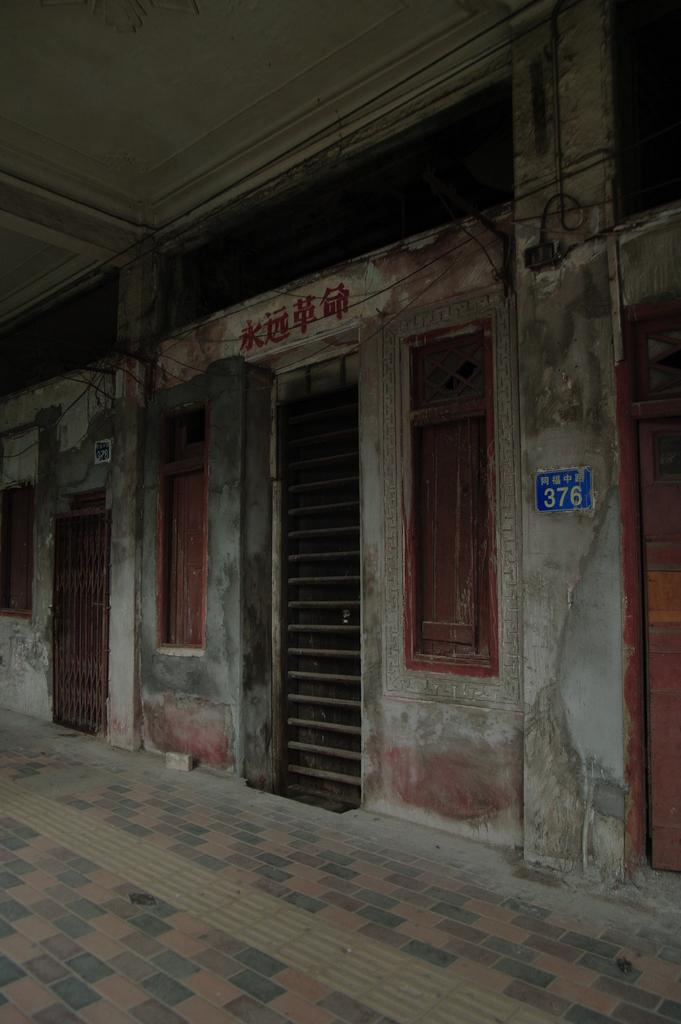What type of openings can be seen in the image? There are windows and a door in the image. What is attached to the wall in the image? There is a blue color poster attached to the wall. What is written on the poster? The poster has something written on it. What is visible above the door and windows in the image? There is a ceiling visible in the image. What type of entrance is present in the image? There is a gate in the image. Can you see any fans in the image? There are no fans visible in the image. Are there any gloves present in the image? There are no gloves present in the image. 